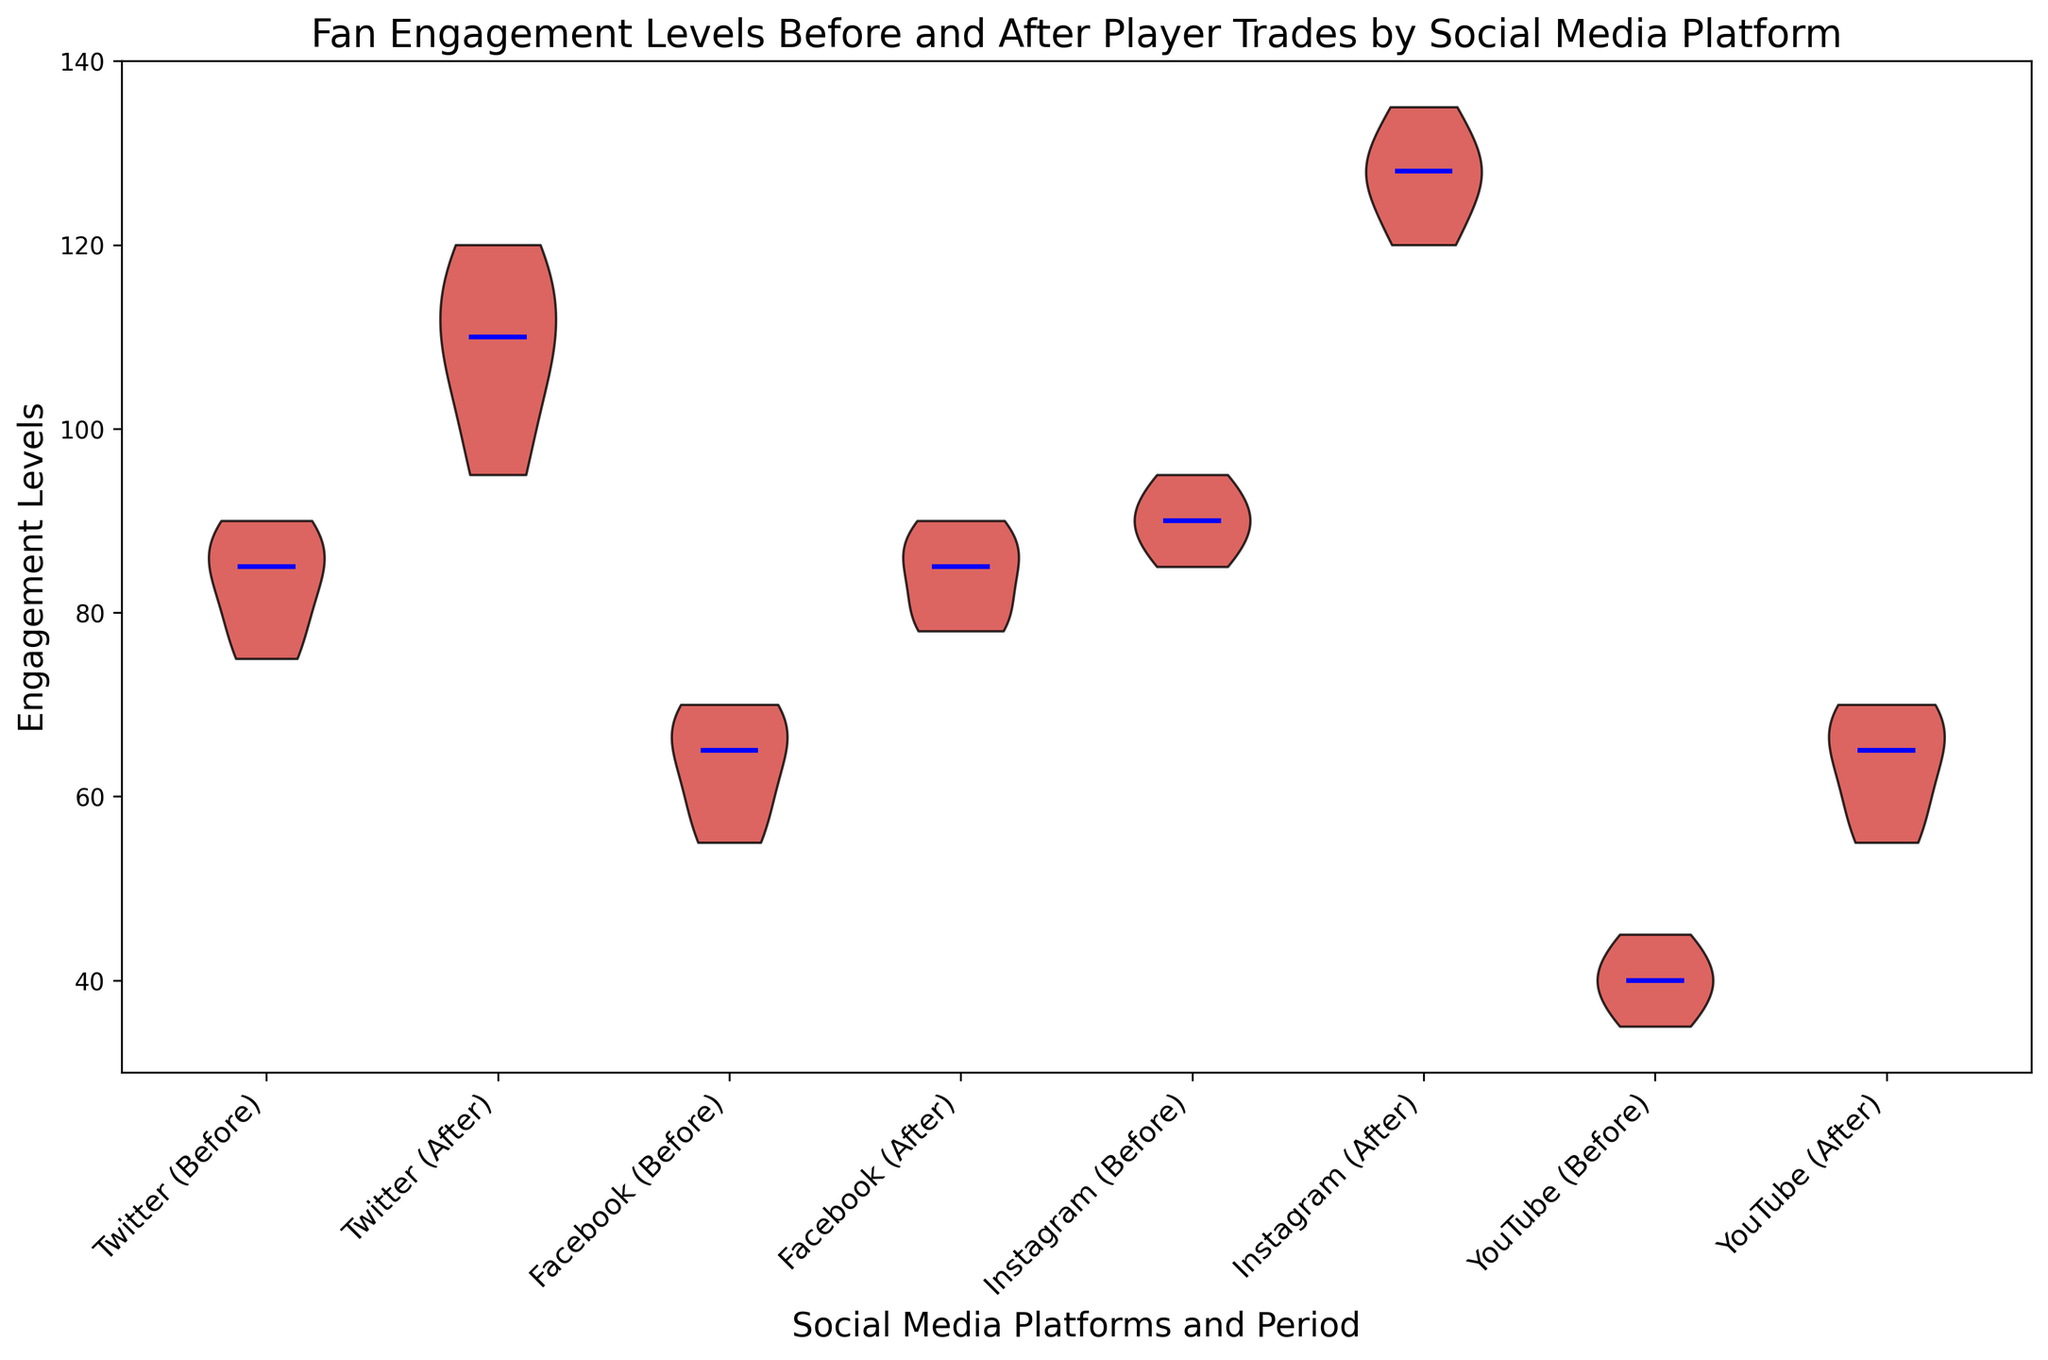What's the median engagement level on Twitter after the trade? The median is the middle value of the data when it is ordered from least to greatest. The engagement levels on Twitter after the trade are 95, 105, 110, 115, 120. The middle value (median) is 110.
Answer: 110 Which platform showed the highest increase in engagement levels after the trade? To determine the increase, compare the median values before and after the trade for each platform. Twitter shows an increase from around 85 to 110, Facebook from around 65 to 85, Instagram from around 90 to 128, and YouTube from around 40 to 65. Instagram shows the highest increase.
Answer: Instagram Which social media platform had the highest median engagement level after the player trades? Identify the medians for the "After" periods: Twitter (110), Facebook (85), Instagram (128), YouTube (65). Instagram has the highest median engagement level.
Answer: Instagram What is the range of engagement levels on Facebook before the trade? The range is the difference between the maximum and minimum values. For Facebook before the trade, the levels are 55, 60, 65, 68, 70. The range is 70 - 55 = 15.
Answer: 15 Between which periods did YouTube see a noticeable change in fan engagement levels? Evaluate the difference in engagement levels between periods. Before the trade, YouTube's levels are 35 to 45, approximately 40; after the trade, they are 55 to 70, approximating 65. The noticeable change is between Before and After the trade.
Answer: Before and After What color represents the median engagement levels in the plot? The plot description states that medians are represented by lines of a specific color, which is blue.
Answer: Blue How do the engagement levels of Instagram before the trade compare to those of Twitter before the trade? Compare the engagement level distributions and medians. Instagram’s median is slightly higher around 90 compared to Twitter’s median around 85.
Answer: Instagram is higher Which platform had the most consistent engagement levels before the trade (smallest range)? Evaluate the range for each platform before the trade: Twitter (75 to 90), Facebook (55 to 70), Instagram (85 to 95), YouTube (35 to 45). Instagram has the smallest range of 10 (95 - 85).
Answer: Instagram How did the engagement levels on Facebook change after the trade, visually? The engagement levels on Facebook after the trade are generally higher, with an increase in both the median and the distribution spread, indicating a positive shift in engagement.
Answer: Increased 